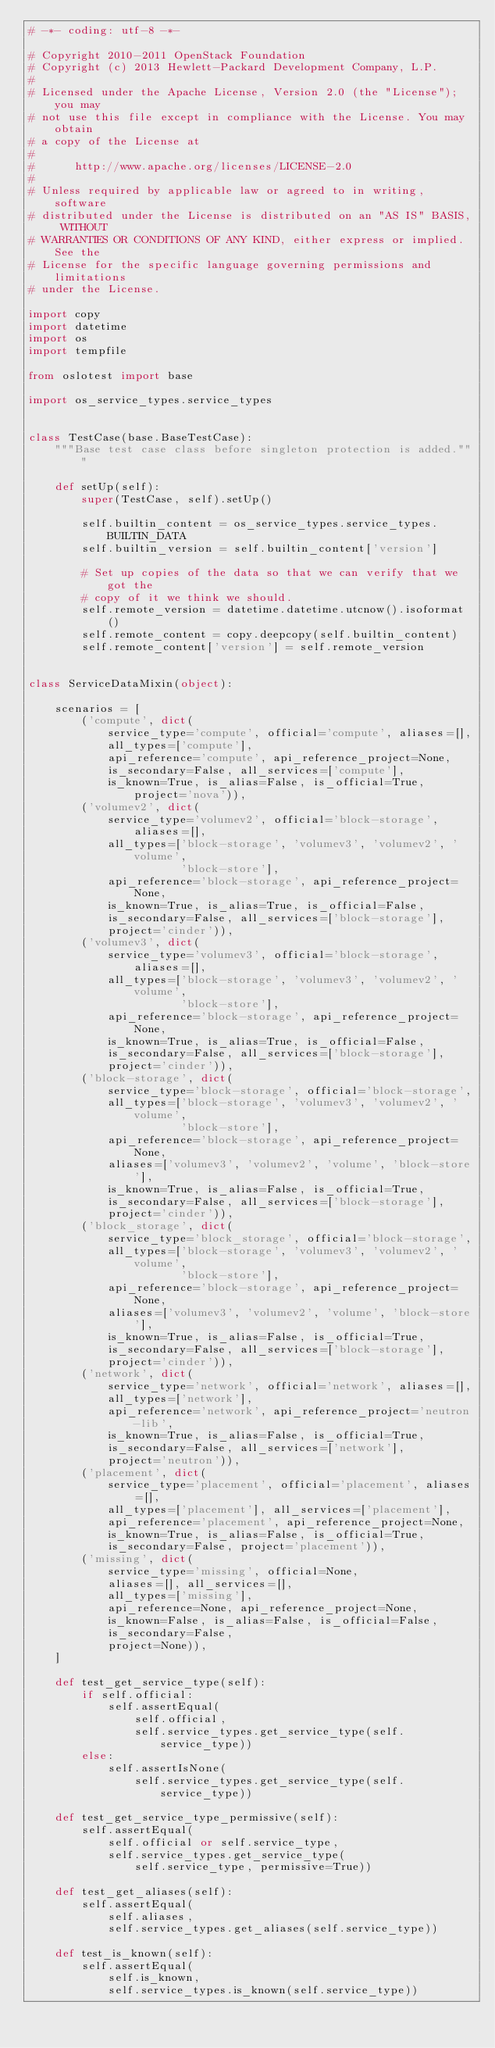Convert code to text. <code><loc_0><loc_0><loc_500><loc_500><_Python_># -*- coding: utf-8 -*-

# Copyright 2010-2011 OpenStack Foundation
# Copyright (c) 2013 Hewlett-Packard Development Company, L.P.
#
# Licensed under the Apache License, Version 2.0 (the "License"); you may
# not use this file except in compliance with the License. You may obtain
# a copy of the License at
#
#      http://www.apache.org/licenses/LICENSE-2.0
#
# Unless required by applicable law or agreed to in writing, software
# distributed under the License is distributed on an "AS IS" BASIS, WITHOUT
# WARRANTIES OR CONDITIONS OF ANY KIND, either express or implied. See the
# License for the specific language governing permissions and limitations
# under the License.

import copy
import datetime
import os
import tempfile

from oslotest import base

import os_service_types.service_types


class TestCase(base.BaseTestCase):
    """Base test case class before singleton protection is added."""

    def setUp(self):
        super(TestCase, self).setUp()

        self.builtin_content = os_service_types.service_types.BUILTIN_DATA
        self.builtin_version = self.builtin_content['version']

        # Set up copies of the data so that we can verify that we got the
        # copy of it we think we should.
        self.remote_version = datetime.datetime.utcnow().isoformat()
        self.remote_content = copy.deepcopy(self.builtin_content)
        self.remote_content['version'] = self.remote_version


class ServiceDataMixin(object):

    scenarios = [
        ('compute', dict(
            service_type='compute', official='compute', aliases=[],
            all_types=['compute'],
            api_reference='compute', api_reference_project=None,
            is_secondary=False, all_services=['compute'],
            is_known=True, is_alias=False, is_official=True, project='nova')),
        ('volumev2', dict(
            service_type='volumev2', official='block-storage', aliases=[],
            all_types=['block-storage', 'volumev3', 'volumev2', 'volume',
                       'block-store'],
            api_reference='block-storage', api_reference_project=None,
            is_known=True, is_alias=True, is_official=False,
            is_secondary=False, all_services=['block-storage'],
            project='cinder')),
        ('volumev3', dict(
            service_type='volumev3', official='block-storage', aliases=[],
            all_types=['block-storage', 'volumev3', 'volumev2', 'volume',
                       'block-store'],
            api_reference='block-storage', api_reference_project=None,
            is_known=True, is_alias=True, is_official=False,
            is_secondary=False, all_services=['block-storage'],
            project='cinder')),
        ('block-storage', dict(
            service_type='block-storage', official='block-storage',
            all_types=['block-storage', 'volumev3', 'volumev2', 'volume',
                       'block-store'],
            api_reference='block-storage', api_reference_project=None,
            aliases=['volumev3', 'volumev2', 'volume', 'block-store'],
            is_known=True, is_alias=False, is_official=True,
            is_secondary=False, all_services=['block-storage'],
            project='cinder')),
        ('block_storage', dict(
            service_type='block_storage', official='block-storage',
            all_types=['block-storage', 'volumev3', 'volumev2', 'volume',
                       'block-store'],
            api_reference='block-storage', api_reference_project=None,
            aliases=['volumev3', 'volumev2', 'volume', 'block-store'],
            is_known=True, is_alias=False, is_official=True,
            is_secondary=False, all_services=['block-storage'],
            project='cinder')),
        ('network', dict(
            service_type='network', official='network', aliases=[],
            all_types=['network'],
            api_reference='network', api_reference_project='neutron-lib',
            is_known=True, is_alias=False, is_official=True,
            is_secondary=False, all_services=['network'],
            project='neutron')),
        ('placement', dict(
            service_type='placement', official='placement', aliases=[],
            all_types=['placement'], all_services=['placement'],
            api_reference='placement', api_reference_project=None,
            is_known=True, is_alias=False, is_official=True,
            is_secondary=False, project='placement')),
        ('missing', dict(
            service_type='missing', official=None,
            aliases=[], all_services=[],
            all_types=['missing'],
            api_reference=None, api_reference_project=None,
            is_known=False, is_alias=False, is_official=False,
            is_secondary=False,
            project=None)),
    ]

    def test_get_service_type(self):
        if self.official:
            self.assertEqual(
                self.official,
                self.service_types.get_service_type(self.service_type))
        else:
            self.assertIsNone(
                self.service_types.get_service_type(self.service_type))

    def test_get_service_type_permissive(self):
        self.assertEqual(
            self.official or self.service_type,
            self.service_types.get_service_type(
                self.service_type, permissive=True))

    def test_get_aliases(self):
        self.assertEqual(
            self.aliases,
            self.service_types.get_aliases(self.service_type))

    def test_is_known(self):
        self.assertEqual(
            self.is_known,
            self.service_types.is_known(self.service_type))
</code> 